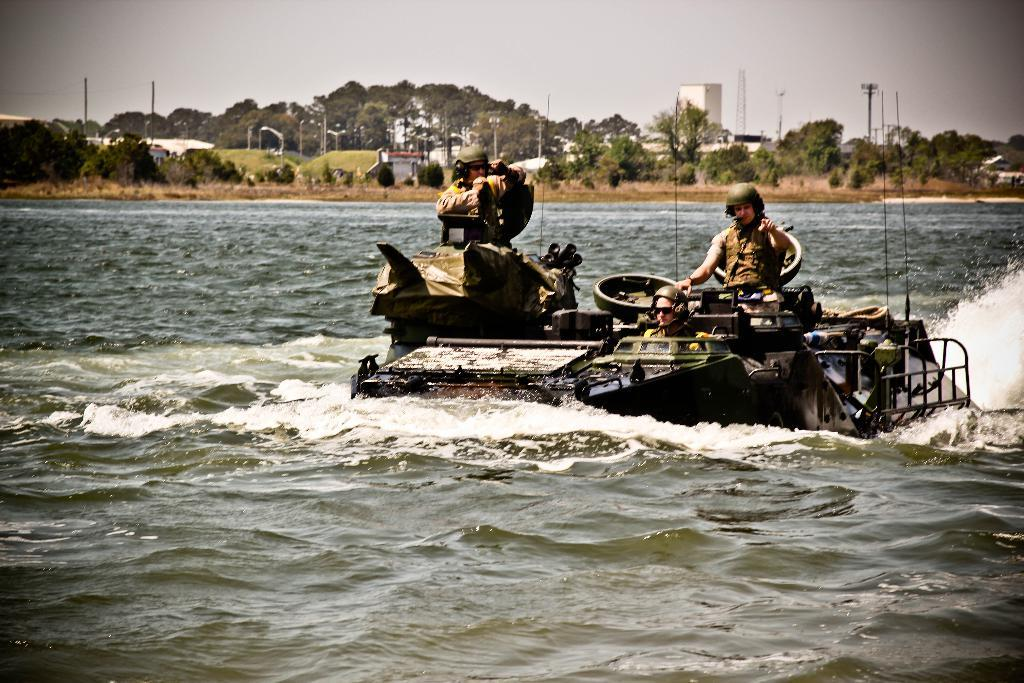What type of vehicle is in the water in the image? There is an armored vehicle in the water in the image. Who is inside the armored vehicle? There are soldiers in the armored vehicle. What can be seen in the background of the image? There are trees and the sky visible in the background of the image. Where is the shelf with the jam located in the image? There is no shelf or jam present in the image. 